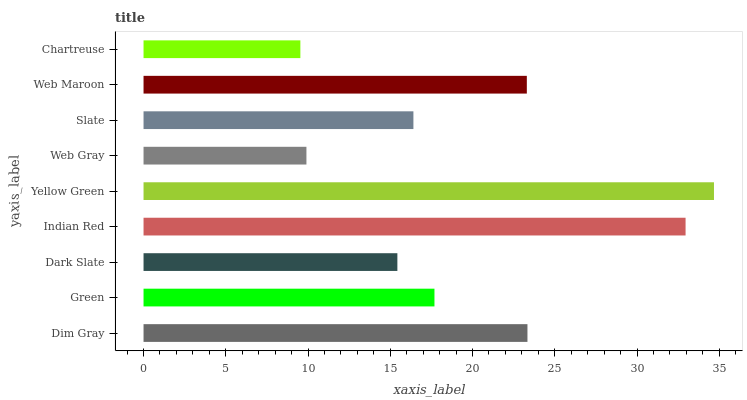Is Chartreuse the minimum?
Answer yes or no. Yes. Is Yellow Green the maximum?
Answer yes or no. Yes. Is Green the minimum?
Answer yes or no. No. Is Green the maximum?
Answer yes or no. No. Is Dim Gray greater than Green?
Answer yes or no. Yes. Is Green less than Dim Gray?
Answer yes or no. Yes. Is Green greater than Dim Gray?
Answer yes or no. No. Is Dim Gray less than Green?
Answer yes or no. No. Is Green the high median?
Answer yes or no. Yes. Is Green the low median?
Answer yes or no. Yes. Is Web Maroon the high median?
Answer yes or no. No. Is Slate the low median?
Answer yes or no. No. 